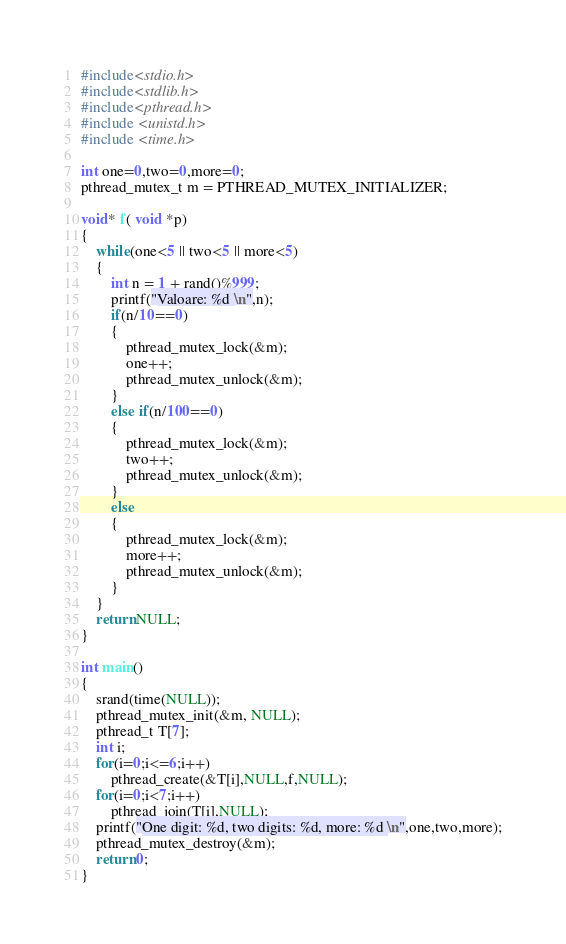Convert code to text. <code><loc_0><loc_0><loc_500><loc_500><_C_>#include<stdio.h>
#include<stdlib.h>
#include<pthread.h>
#include <unistd.h>
#include <time.h>

int one=0,two=0,more=0;
pthread_mutex_t m = PTHREAD_MUTEX_INITIALIZER;

void* f( void *p)
{
    while(one<5 || two<5 || more<5)
    {
        int n = 1 + rand()%999;
        printf("Valoare: %d \n",n);
        if(n/10==0)
        {
            pthread_mutex_lock(&m);
            one++;
            pthread_mutex_unlock(&m);
        }
        else if(n/100==0)
        {
            pthread_mutex_lock(&m);
            two++;
            pthread_mutex_unlock(&m);
        }
        else
        {
            pthread_mutex_lock(&m);
            more++;
            pthread_mutex_unlock(&m);
        }
    }
    return NULL;
}

int main()
{
    srand(time(NULL));
    pthread_mutex_init(&m, NULL);
    pthread_t T[7];
    int i;
    for(i=0;i<=6;i++)
        pthread_create(&T[i],NULL,f,NULL);
    for(i=0;i<7;i++)
        pthread_join(T[i],NULL);
    printf("One digit: %d, two digits: %d, more: %d \n",one,two,more);
    pthread_mutex_destroy(&m);
    return 0;
}
</code> 